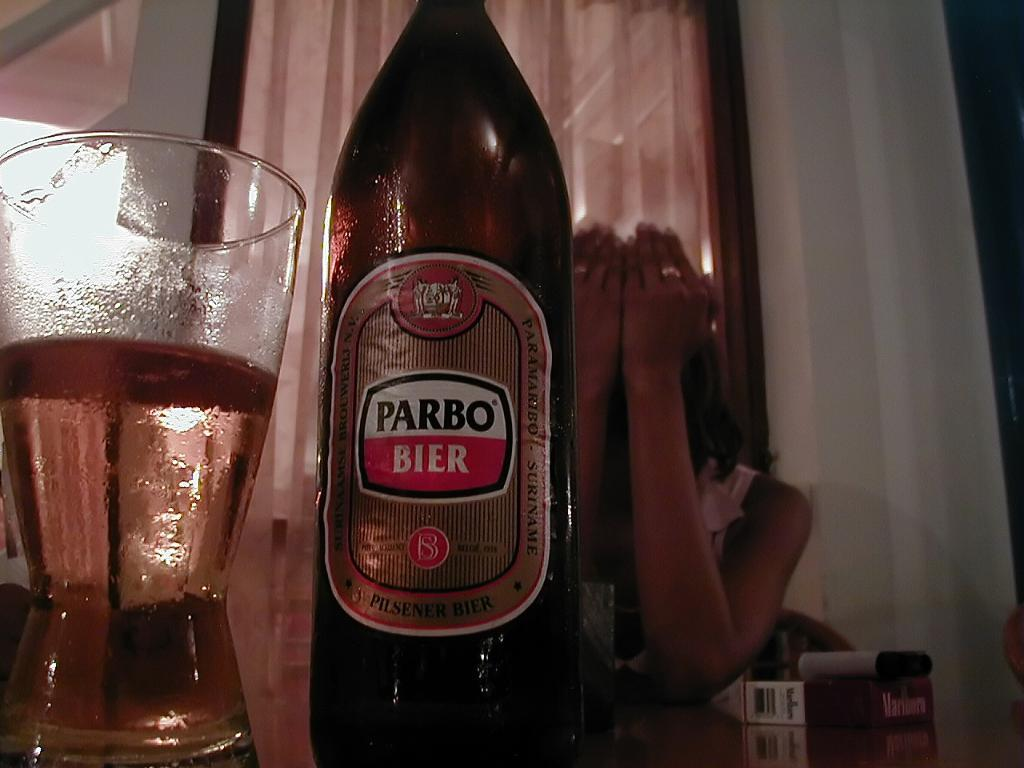Provide a one-sentence caption for the provided image. A woman sits at a table with her hands covering her face and a bottle and partially filled glass of Parbo Bier in front of her. 